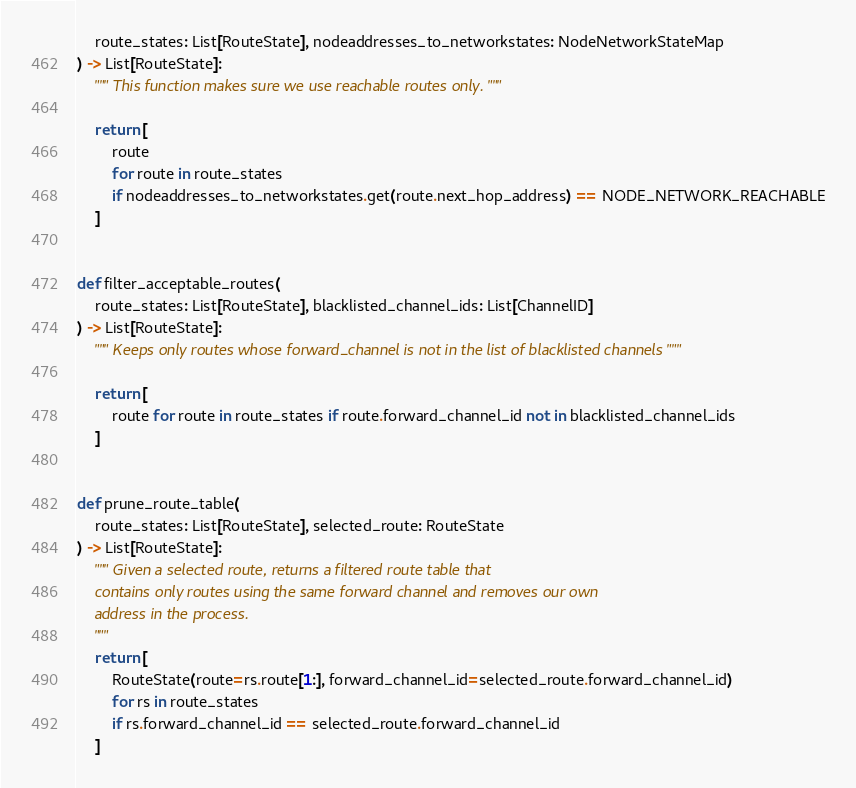<code> <loc_0><loc_0><loc_500><loc_500><_Python_>    route_states: List[RouteState], nodeaddresses_to_networkstates: NodeNetworkStateMap
) -> List[RouteState]:
    """ This function makes sure we use reachable routes only. """

    return [
        route
        for route in route_states
        if nodeaddresses_to_networkstates.get(route.next_hop_address) == NODE_NETWORK_REACHABLE
    ]


def filter_acceptable_routes(
    route_states: List[RouteState], blacklisted_channel_ids: List[ChannelID]
) -> List[RouteState]:
    """ Keeps only routes whose forward_channel is not in the list of blacklisted channels """

    return [
        route for route in route_states if route.forward_channel_id not in blacklisted_channel_ids
    ]


def prune_route_table(
    route_states: List[RouteState], selected_route: RouteState
) -> List[RouteState]:
    """ Given a selected route, returns a filtered route table that
    contains only routes using the same forward channel and removes our own
    address in the process.
    """
    return [
        RouteState(route=rs.route[1:], forward_channel_id=selected_route.forward_channel_id)
        for rs in route_states
        if rs.forward_channel_id == selected_route.forward_channel_id
    ]
</code> 